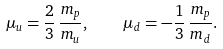<formula> <loc_0><loc_0><loc_500><loc_500>\mu _ { u } = \frac { 2 } { 3 } \, \frac { m _ { p } } { m _ { u } } , \quad \mu _ { d } = - \frac { 1 } { 3 } \, \frac { m _ { p } } { m _ { d } } .</formula> 